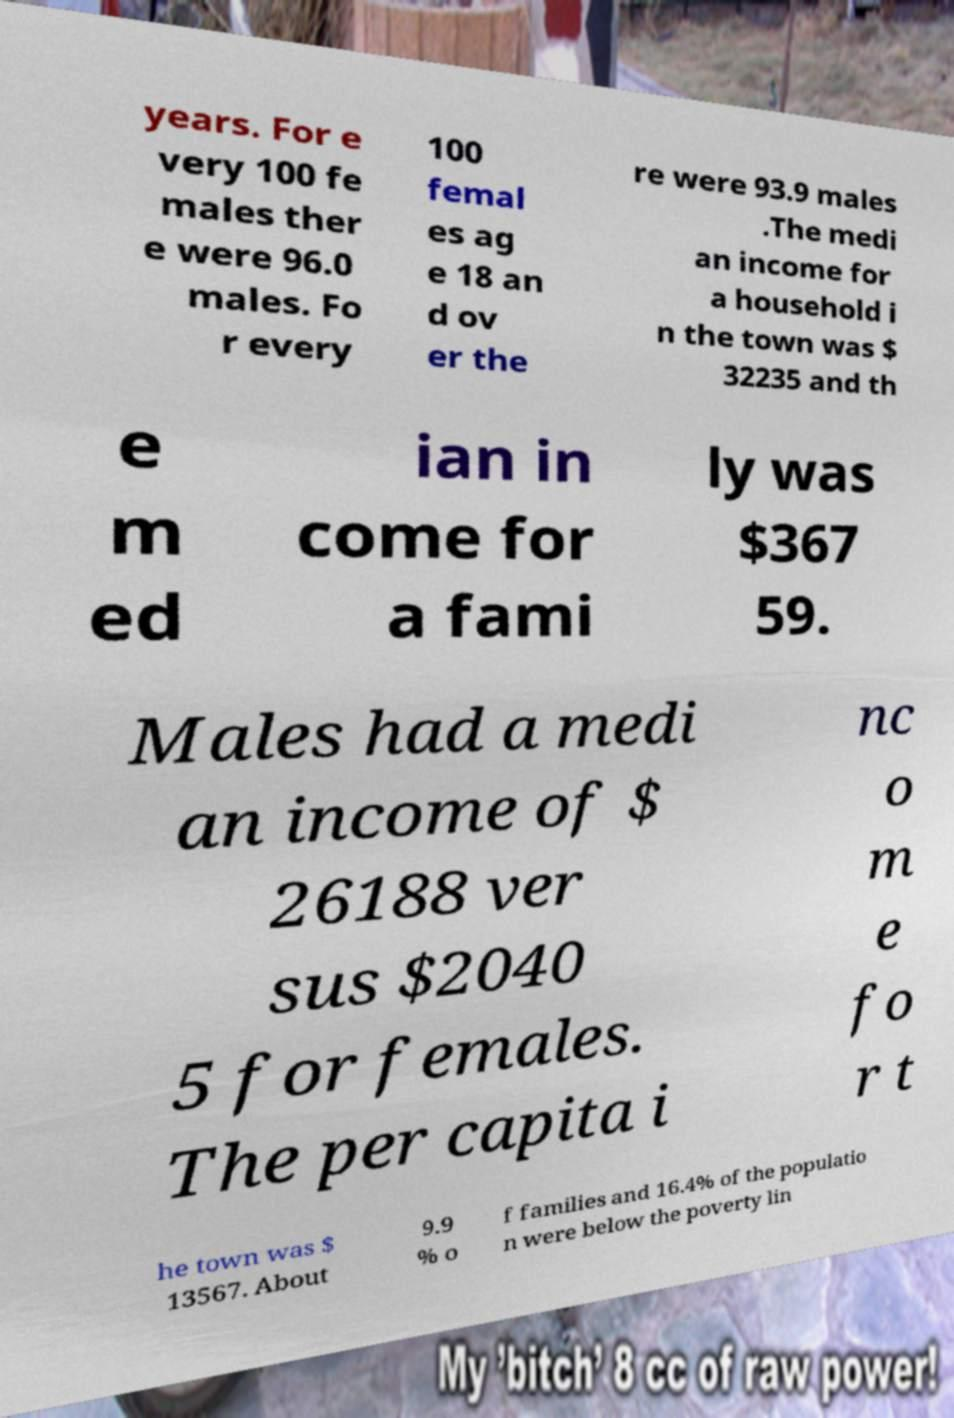Could you assist in decoding the text presented in this image and type it out clearly? years. For e very 100 fe males ther e were 96.0 males. Fo r every 100 femal es ag e 18 an d ov er the re were 93.9 males .The medi an income for a household i n the town was $ 32235 and th e m ed ian in come for a fami ly was $367 59. Males had a medi an income of $ 26188 ver sus $2040 5 for females. The per capita i nc o m e fo r t he town was $ 13567. About 9.9 % o f families and 16.4% of the populatio n were below the poverty lin 